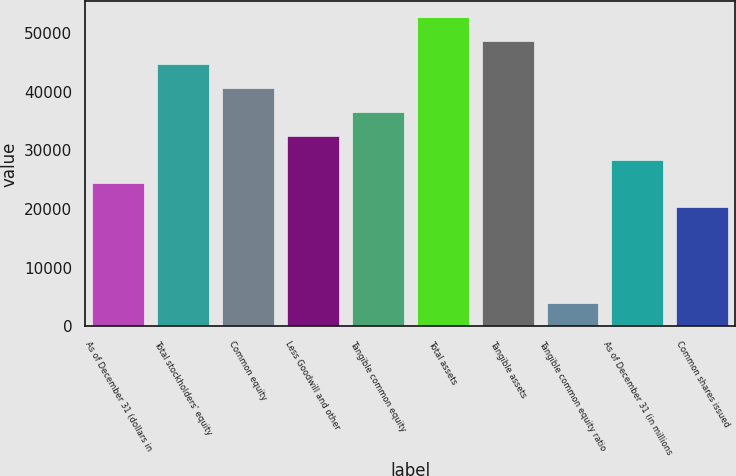<chart> <loc_0><loc_0><loc_500><loc_500><bar_chart><fcel>As of December 31 (dollars in<fcel>Total stockholders' equity<fcel>Common equity<fcel>Less Goodwill and other<fcel>Tangible common equity<fcel>Total assets<fcel>Tangible assets<fcel>Tangible common equity ratio<fcel>As of December 31 (in millions<fcel>Common shares issued<nl><fcel>24368.8<fcel>44670.3<fcel>40610<fcel>32489.4<fcel>36549.7<fcel>52790.9<fcel>48730.6<fcel>4067.27<fcel>28429.1<fcel>20308.5<nl></chart> 